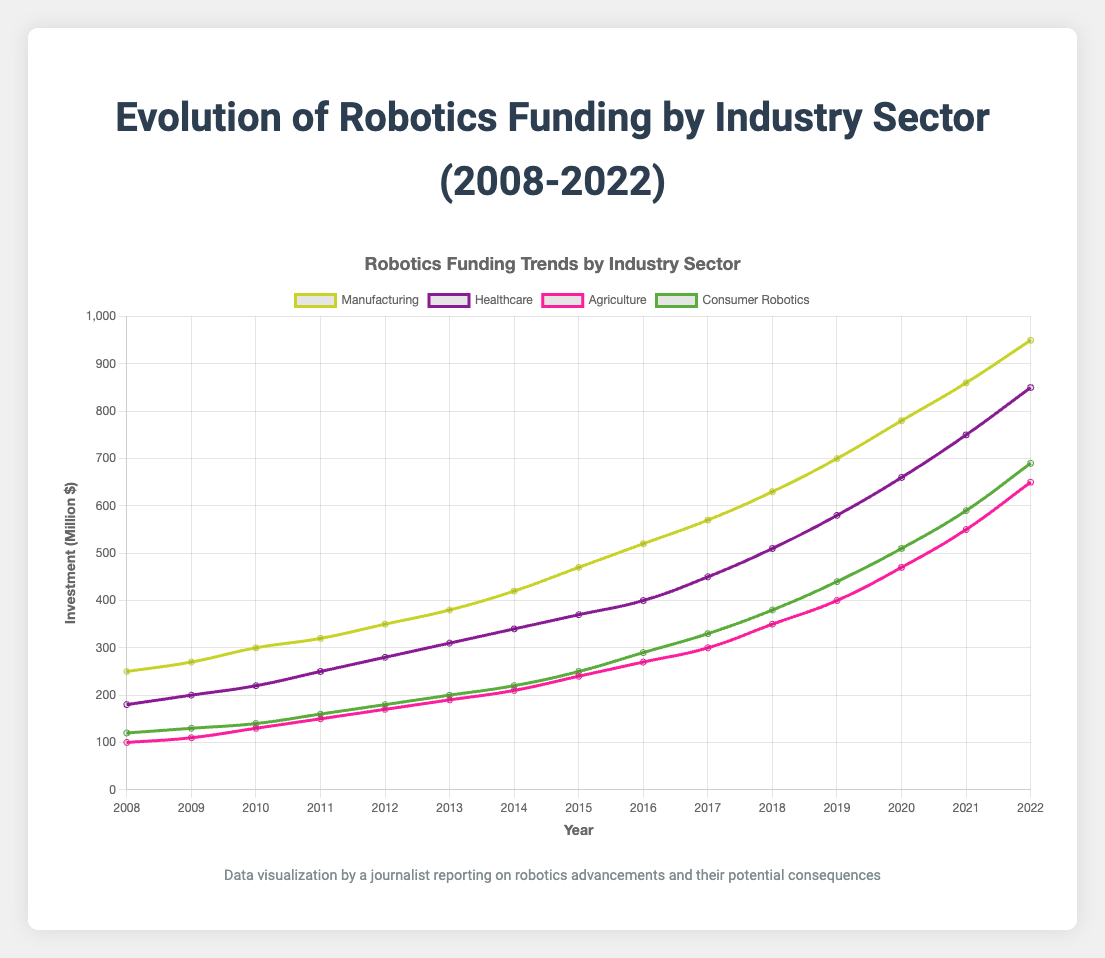Which industry sector had the highest investment in 2022? The plot shows various industry sectors with their investment values over the years. By looking at the graph for 2022, we can see which sector has the highest investment value.
Answer: Manufacturing How did the investment in the Healthcare sector change from 2008 to 2022? Locate the investment value for Healthcare in the years 2008 and 2022 on the plot. Compare the values; 180 million in 2008 and 850 million in 2022, indicating an increase.
Answer: Increased Which industry sector saw the highest relative increase in investment from 2008 to 2022? To determine the highest relative increase, calculate the percentage increase for each industry sector using the formula [(investment in 2022 - investment in 2008)/investment in 2008]*100%. Compare the results for all sectors. Healthcare increased from 180 to 850 million, around 372%.
Answer: Healthcare In which year did investments in the Consumer Robotics sector first surpass 400 million? Check the graph for the Consumer Robotics sector over the years and identify the first year where the investment exceeded 400 million. The graph shows it was in 2019 with an investment of 440 million.
Answer: 2019 What was the combined investment in both Manufacturing and Healthcare sectors in 2020? Locate the investments for both sectors in 2020 on the plot: Manufacturing (780 million) and Healthcare (660 million). Add them together: 780 + 660 = 1440 million.
Answer: 1440 million What trend is observed in the investment for the Agriculture sector from 2008 to 2022? Observe the plot for the Agriculture sector from 2008 through 2022. The trend shows a steady increase from 100 million in 2008 to 650 million in 2022.
Answer: Steady increase How did the investment in Manufacturing change from 2010 to 2013? Look at the investment values for Manufacturing from 2010 to 2013. In 2010, it was 300 million, and in 2013, it was 380 million, showing an increase of 80 million.
Answer: Increased Which year between 2015 and 2018 had the lowest investment in Healthcare? Locate the investments for Healthcare for the years 2015 to 2018 on the plot. 2015 had 370 million, 2016 had 400 million, 2017 had 450 million, and 2018 had 510 million. The lowest value is in 2015.
Answer: 2015 What was the average investment in Consumer Robotics over the last 5 years (2018-2022)? Sum the investment values for Consumer Robotics from 2018 to 2022 and divide by 5. Values are 380 + 440 + 510 + 590 + 690 = 2610. Then, 2610/5 = 522 million.
Answer: 522 million 